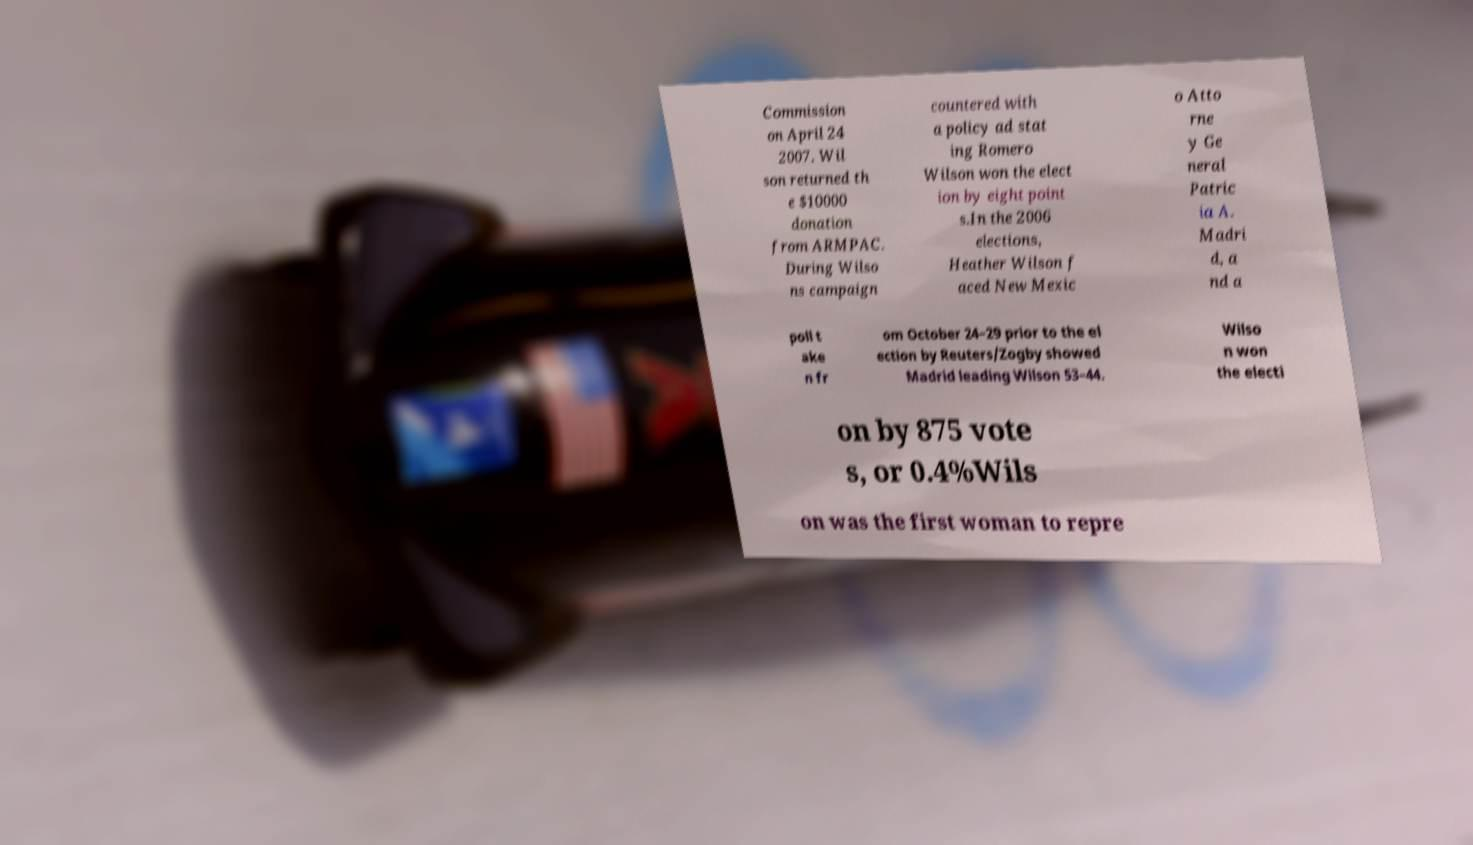Please identify and transcribe the text found in this image. Commission on April 24 2007. Wil son returned th e $10000 donation from ARMPAC. During Wilso ns campaign countered with a policy ad stat ing Romero Wilson won the elect ion by eight point s.In the 2006 elections, Heather Wilson f aced New Mexic o Atto rne y Ge neral Patric ia A. Madri d, a nd a poll t ake n fr om October 24–29 prior to the el ection by Reuters/Zogby showed Madrid leading Wilson 53–44. Wilso n won the electi on by 875 vote s, or 0.4%Wils on was the first woman to repre 